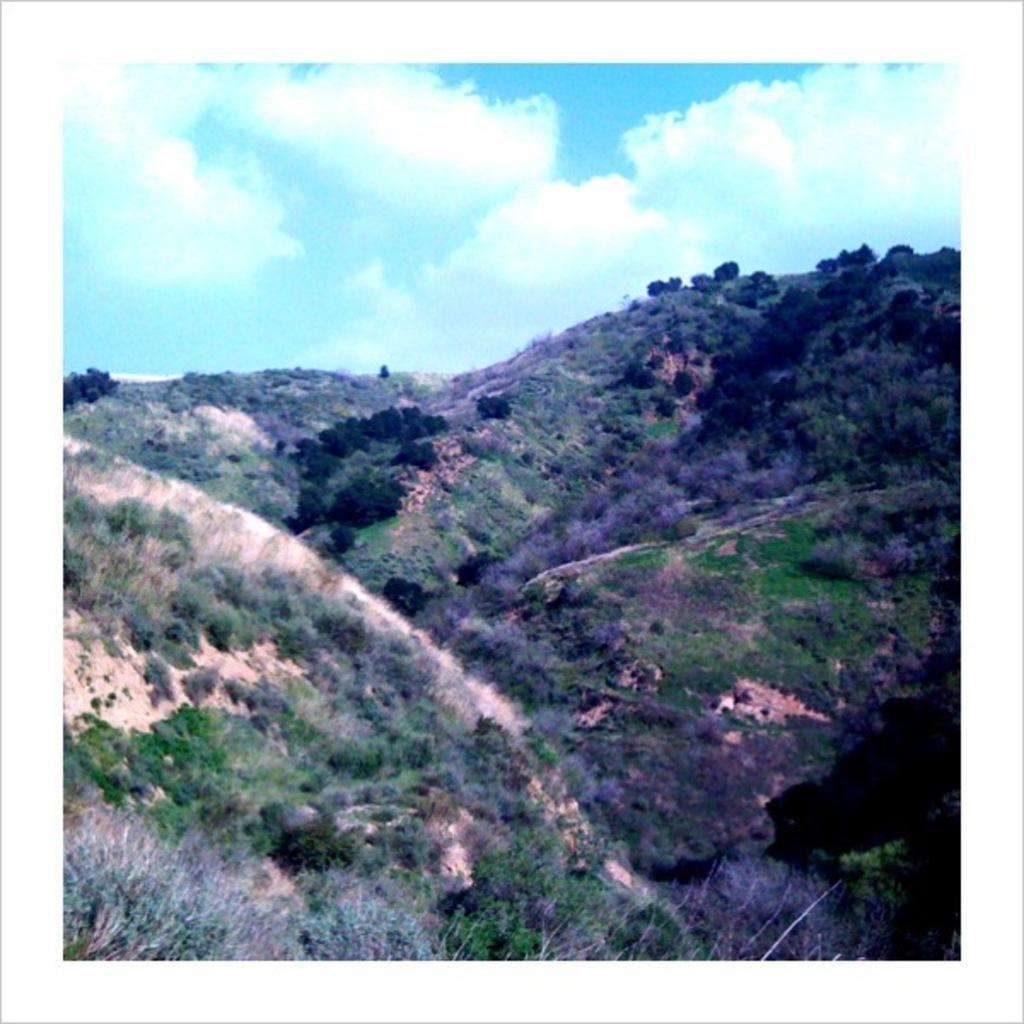How would you summarize this image in a sentence or two? In this image, we can see a photo, we can see some plants, hills and the sky. 